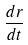<formula> <loc_0><loc_0><loc_500><loc_500>\frac { d r } { d t }</formula> 